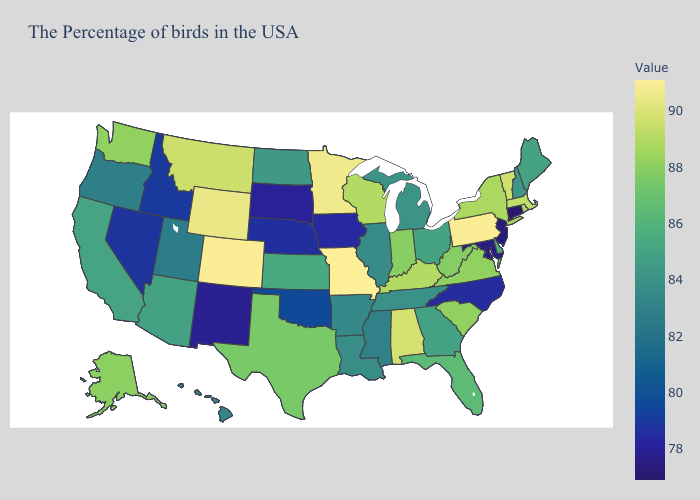Among the states that border Pennsylvania , does Delaware have the lowest value?
Keep it brief. No. Among the states that border Iowa , does South Dakota have the highest value?
Answer briefly. No. Which states hav the highest value in the Northeast?
Give a very brief answer. Pennsylvania. 